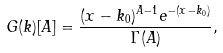Convert formula to latex. <formula><loc_0><loc_0><loc_500><loc_500>G ( k ) [ A ] = \frac { ( x - k _ { 0 } ) ^ { A - 1 } e ^ { - ( x - k _ { 0 } ) } } { \Gamma ( A ) } ,</formula> 